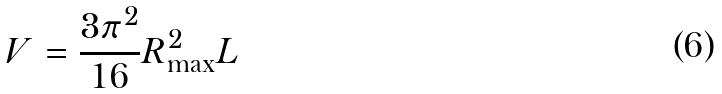Convert formula to latex. <formula><loc_0><loc_0><loc_500><loc_500>V = \frac { 3 \pi ^ { 2 } } { 1 6 } R _ { \max } ^ { 2 } L</formula> 